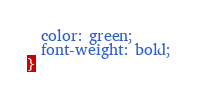<code> <loc_0><loc_0><loc_500><loc_500><_CSS_>  color: green;
  font-weight: bold;
}
</code> 